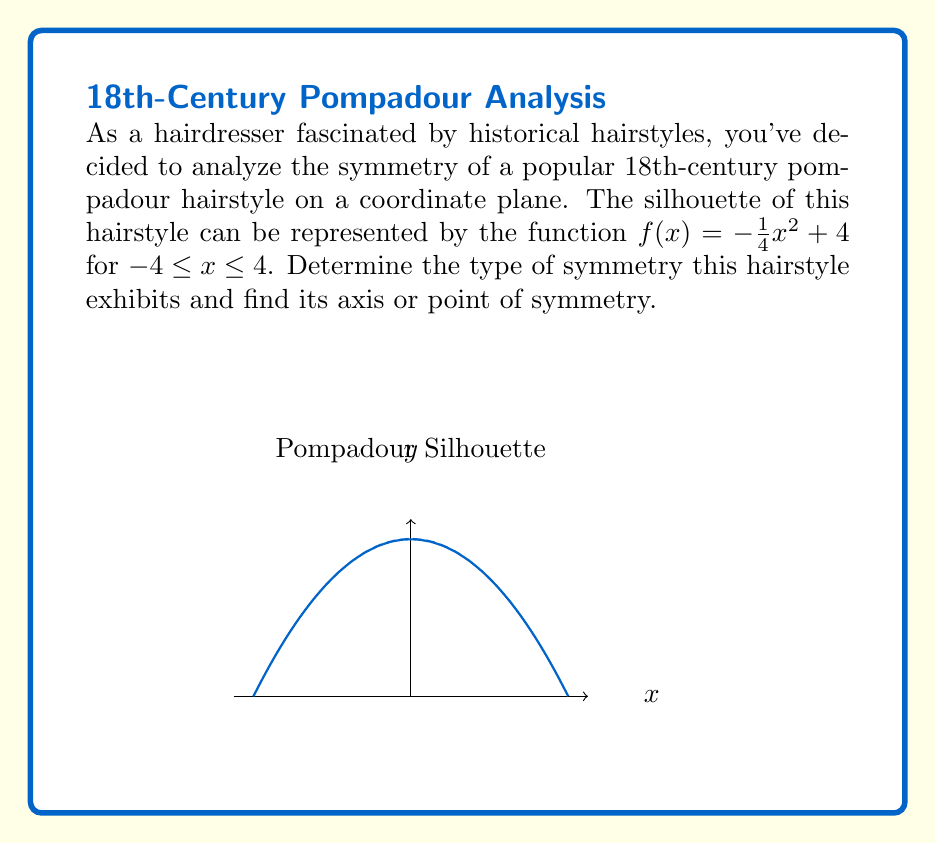Give your solution to this math problem. Let's approach this step-by-step:

1) To determine the symmetry, we need to check if the function is even, odd, or neither.

2) For even functions: $f(-x) = f(x)$
   For odd functions: $f(-x) = -f(x)$

3) Let's test $f(-x)$:
   $f(-x) = -\frac{1}{4}(-x)^2 + 4$
   $= -\frac{1}{4}x^2 + 4$
   $= f(x)$

4) Since $f(-x) = f(x)$, the function is even.

5) Even functions are symmetric about the y-axis.

6) The axis of symmetry for even functions is always the y-axis, which has the equation $x = 0$.

7) We can also verify this visually from the graph. The parabola is centered at the y-axis.

Therefore, the hairstyle exhibits symmetry about the y-axis, with the axis of symmetry being $x = 0$.
Answer: Even symmetry; axis of symmetry: $x = 0$ 